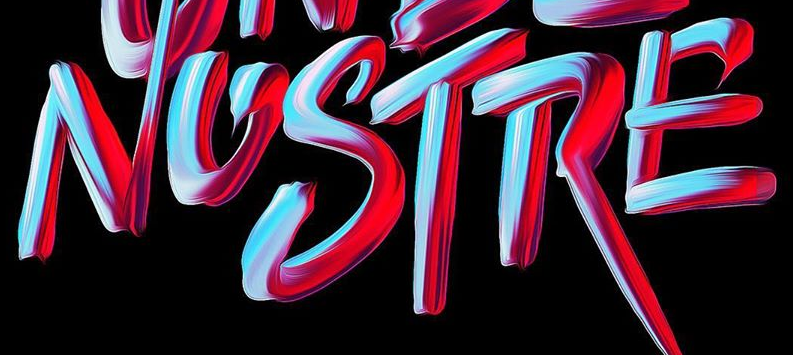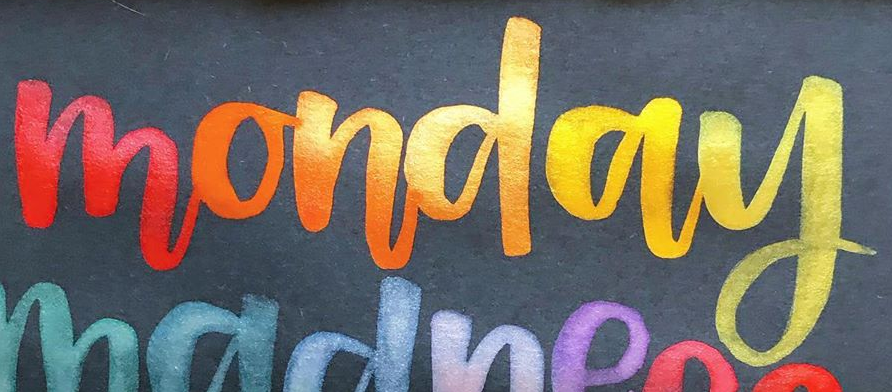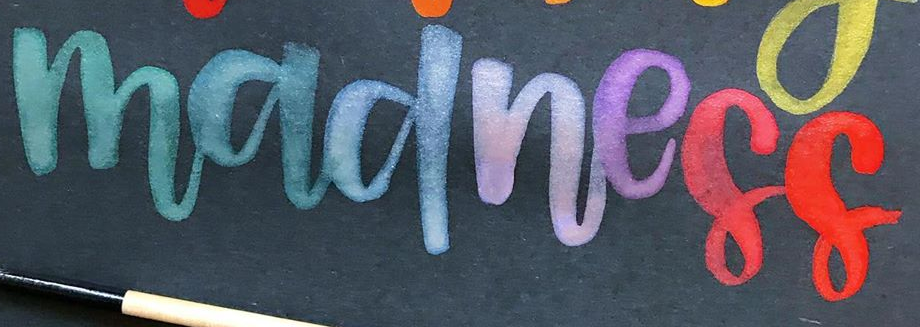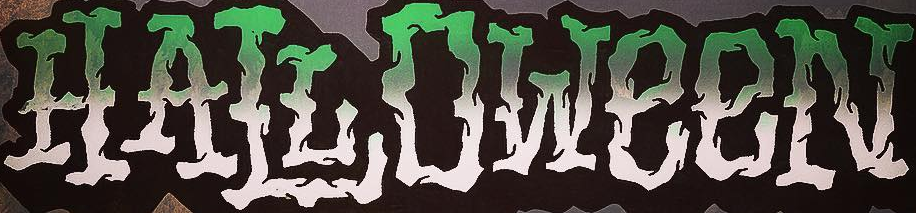Read the text from these images in sequence, separated by a semicolon. NOSTRE; monday; madness; HALLOWeeN 